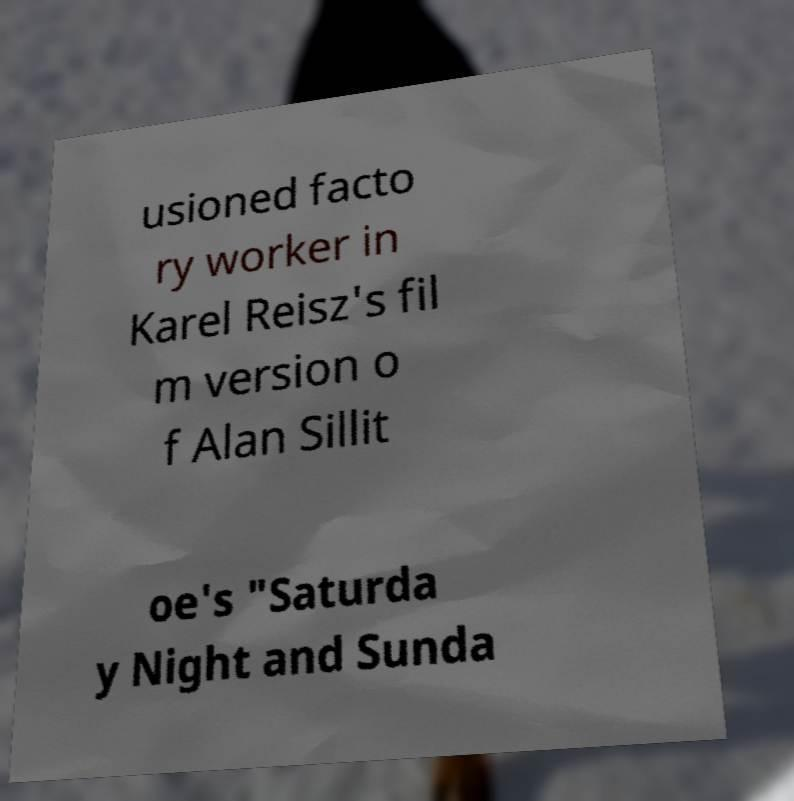Could you extract and type out the text from this image? usioned facto ry worker in Karel Reisz's fil m version o f Alan Sillit oe's "Saturda y Night and Sunda 